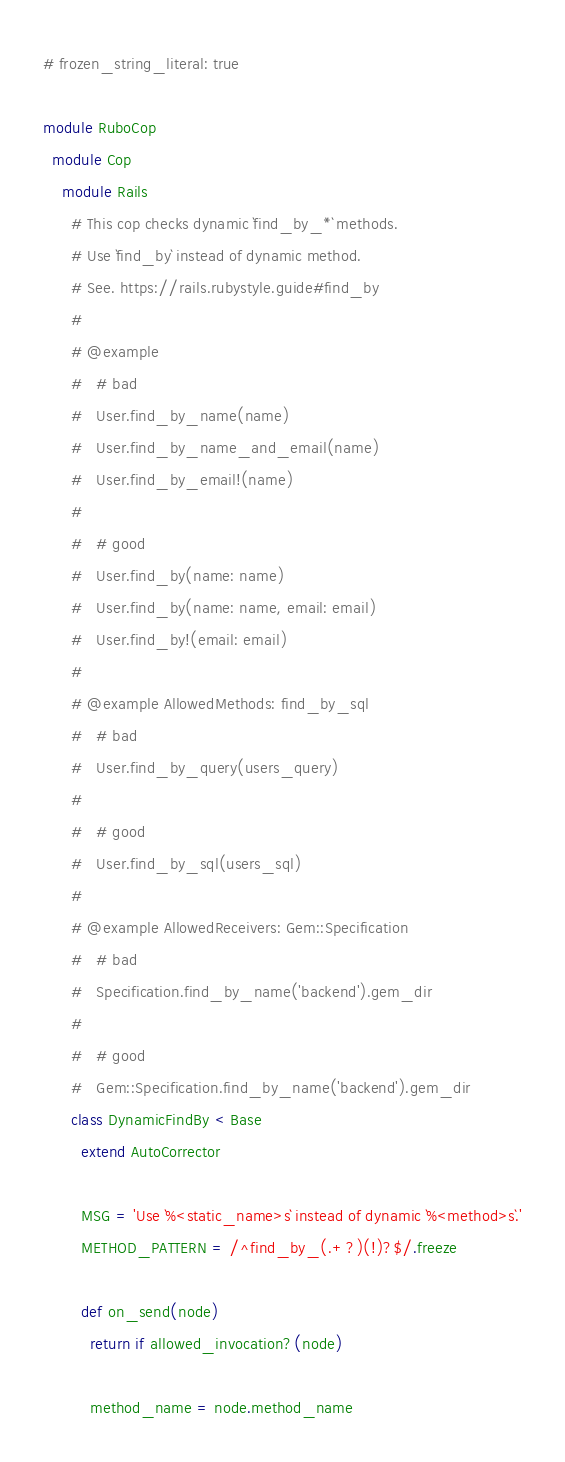Convert code to text. <code><loc_0><loc_0><loc_500><loc_500><_Ruby_># frozen_string_literal: true

module RuboCop
  module Cop
    module Rails
      # This cop checks dynamic `find_by_*` methods.
      # Use `find_by` instead of dynamic method.
      # See. https://rails.rubystyle.guide#find_by
      #
      # @example
      #   # bad
      #   User.find_by_name(name)
      #   User.find_by_name_and_email(name)
      #   User.find_by_email!(name)
      #
      #   # good
      #   User.find_by(name: name)
      #   User.find_by(name: name, email: email)
      #   User.find_by!(email: email)
      #
      # @example AllowedMethods: find_by_sql
      #   # bad
      #   User.find_by_query(users_query)
      #
      #   # good
      #   User.find_by_sql(users_sql)
      #
      # @example AllowedReceivers: Gem::Specification
      #   # bad
      #   Specification.find_by_name('backend').gem_dir
      #
      #   # good
      #   Gem::Specification.find_by_name('backend').gem_dir
      class DynamicFindBy < Base
        extend AutoCorrector

        MSG = 'Use `%<static_name>s` instead of dynamic `%<method>s`.'
        METHOD_PATTERN = /^find_by_(.+?)(!)?$/.freeze

        def on_send(node)
          return if allowed_invocation?(node)

          method_name = node.method_name</code> 